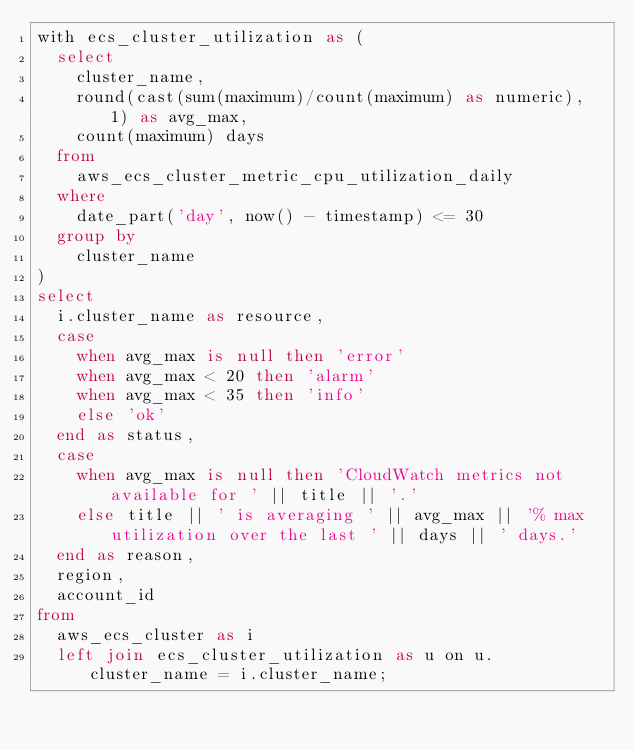Convert code to text. <code><loc_0><loc_0><loc_500><loc_500><_SQL_>with ecs_cluster_utilization as (
  select
    cluster_name,
    round(cast(sum(maximum)/count(maximum) as numeric), 1) as avg_max,
    count(maximum) days
  from
    aws_ecs_cluster_metric_cpu_utilization_daily
  where
    date_part('day', now() - timestamp) <= 30
  group by
    cluster_name
)
select
  i.cluster_name as resource,
  case
    when avg_max is null then 'error'
    when avg_max < 20 then 'alarm'
    when avg_max < 35 then 'info'
    else 'ok'
  end as status,
  case
    when avg_max is null then 'CloudWatch metrics not available for ' || title || '.'
    else title || ' is averaging ' || avg_max || '% max utilization over the last ' || days || ' days.'
  end as reason,
  region,
  account_id
from
  aws_ecs_cluster as i
  left join ecs_cluster_utilization as u on u.cluster_name = i.cluster_name;</code> 